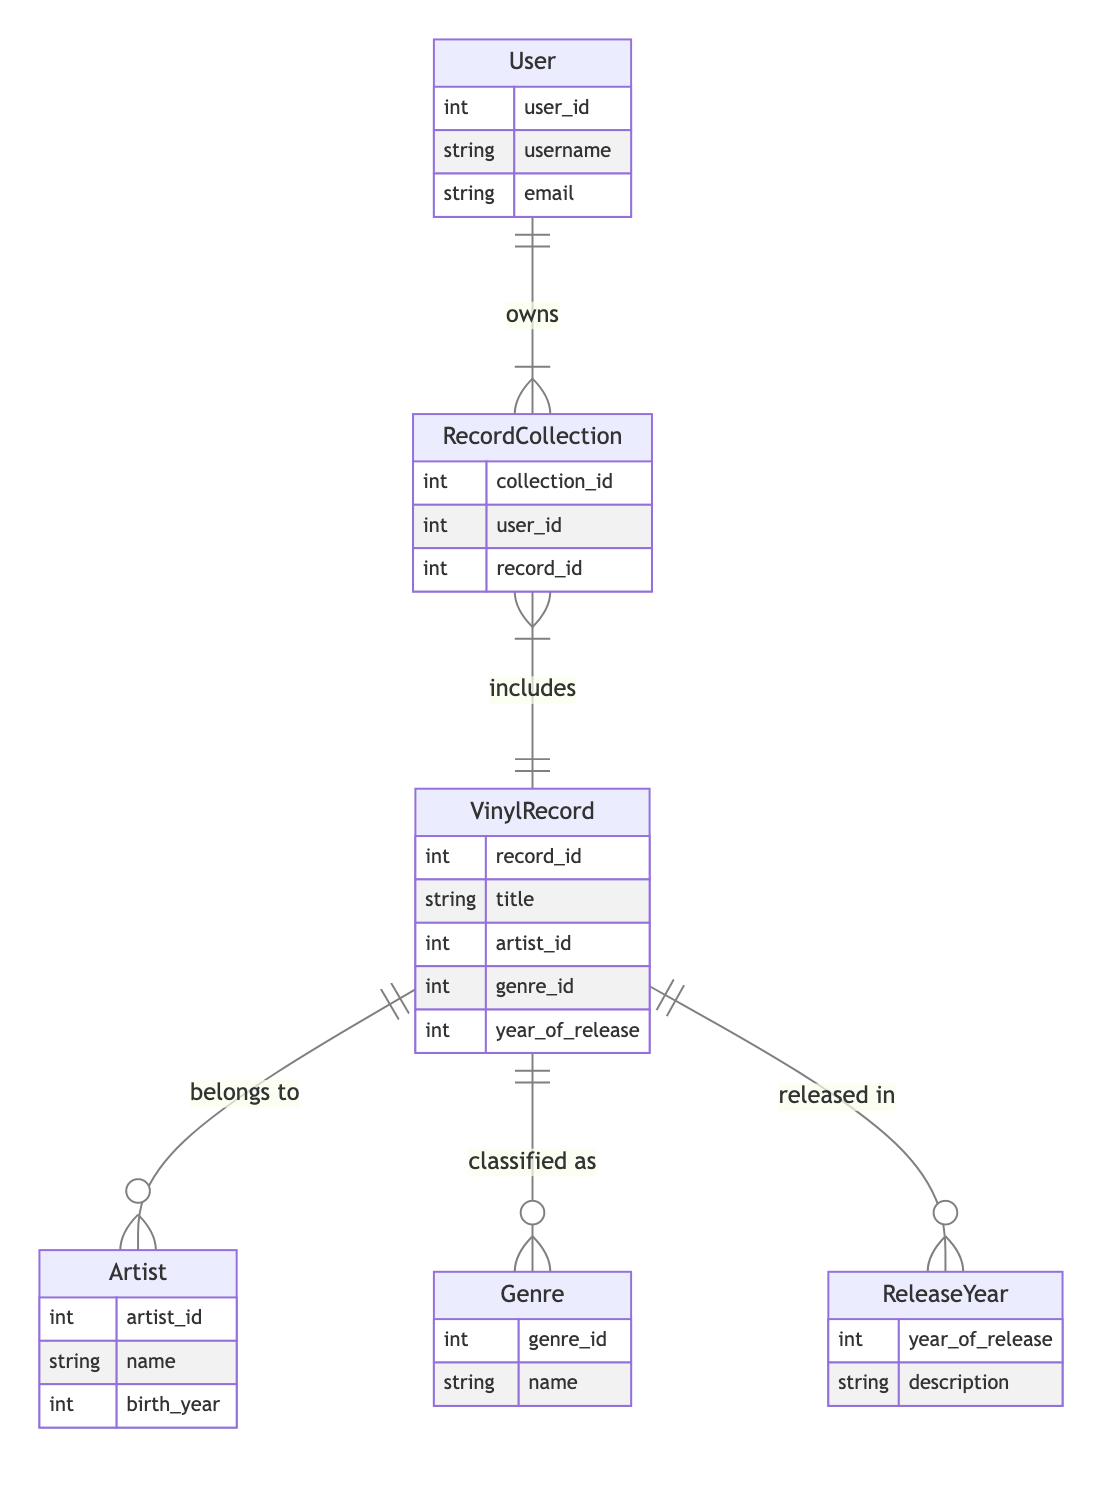What entity represents the collection of records owned by a user? The diagram shows that the entity called "RecordCollection" relates to the "User" entity with a one-to-many relationship, indicating that a user can own multiple records collected. Therefore, the entity responsible for collection ownership is "RecordCollection."
Answer: RecordCollection How many relationships are represented in this diagram? By examining the relationships section of the diagram, we see there are five defined relationships between different entities (VinylRecord and Artist, VinylRecord and Genre, VinylRecord and ReleaseYear, User and RecordCollection, and RecordCollection and VinylRecord). Thus, there are a total of five relationships.
Answer: Five What is the cardinality of the relationship between VinylRecord and Artist? The diagram indicates that the relationship between "VinylRecord" and "Artist" is shown as "many_to_one," suggesting that multiple vinyl records can belong to a single artist, while each record references only one artist.
Answer: Many to one What is the primary attribute for the Genre entity? Looking at the attributes within the "Genre" entity in the diagram, the primary attribute listed is "genre_id," which uniquely identifies each genre in the collection.
Answer: Genre ID In which entity can you find the year of release for vinyl records? The "year_of_release" attribute is specifically noted in the "VinylRecord" entity, indicating that this entity directly includes the year in which each record was released.
Answer: VinylRecord What type of relationship exists between User and RecordCollection? According to the diagram, the relationship between "User" and "RecordCollection" is described as "owns," with a cardinality of one-to-many, indicating a user can own multiple collections.
Answer: Owns Which entity provides descriptions of release years? The diagram features the "ReleaseYear" entity, which includes the "description" attribute that is intended to provide additional context about each specific year of release.
Answer: ReleaseYear What entity would you reference to find the name of an artist? To find the name of an artist, you would reference the "Artist" entity, which includes attributes like "name" and "birth_year." The name is specifically the information required here.
Answer: Artist What relationship defines how records are linked to a user's collection? The "includes" relationship between the "RecordCollection" and "VinylRecord" entities outlines how individual records are part of a user's collection, demonstrating the many-to-many association between them.
Answer: Includes 